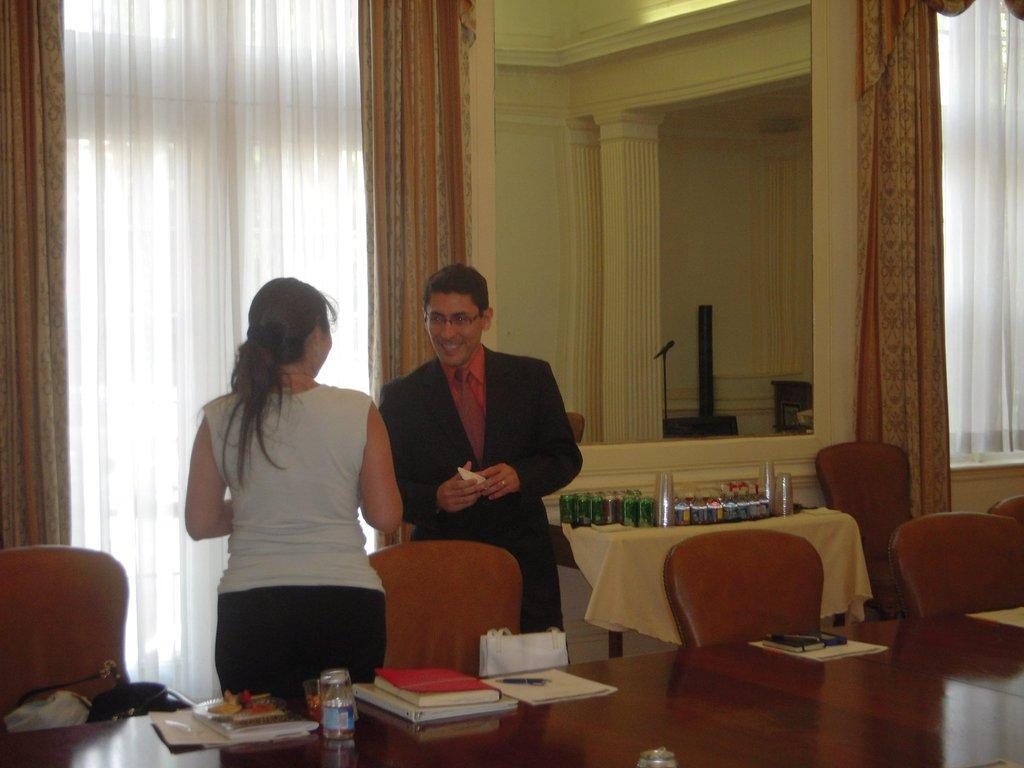How would you summarize this image in a sentence or two? As we can see in the image there is yellow color wall, curtains, two people standing over here and there are chairs and tables. On tables there are books, pens and mobile phone. 